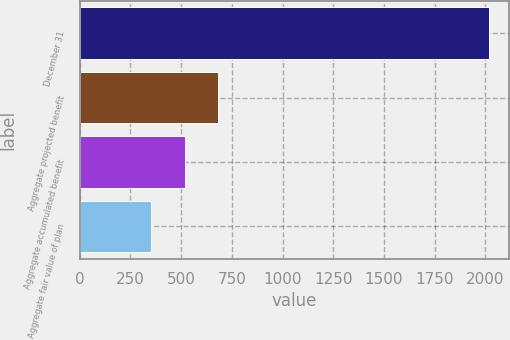Convert chart to OTSL. <chart><loc_0><loc_0><loc_500><loc_500><bar_chart><fcel>December 31<fcel>Aggregate projected benefit<fcel>Aggregate accumulated benefit<fcel>Aggregate fair value of plan<nl><fcel>2018<fcel>684<fcel>517.25<fcel>350.5<nl></chart> 